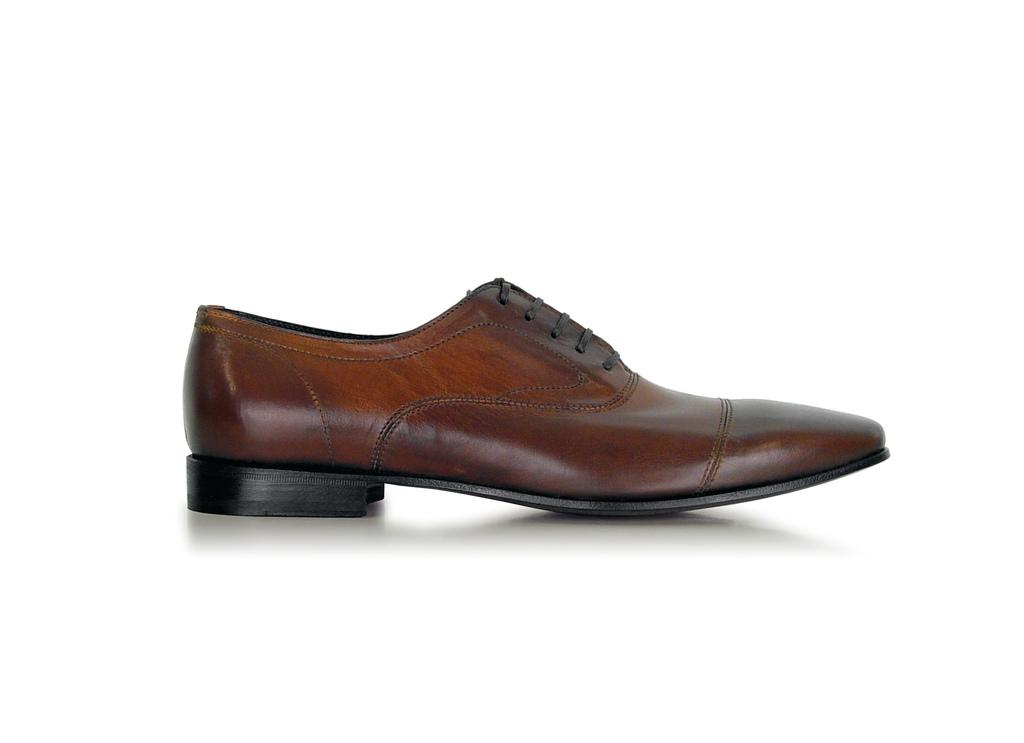What type of shoe is visible in the image? There is a brown color shoe in the image. What color is the background of the image? The background of the image is white. What is there a way to exchange the shoe for a different color in the image? There is no indication in the image that a shoe exchange is taking place or that there are multiple shoes available. 